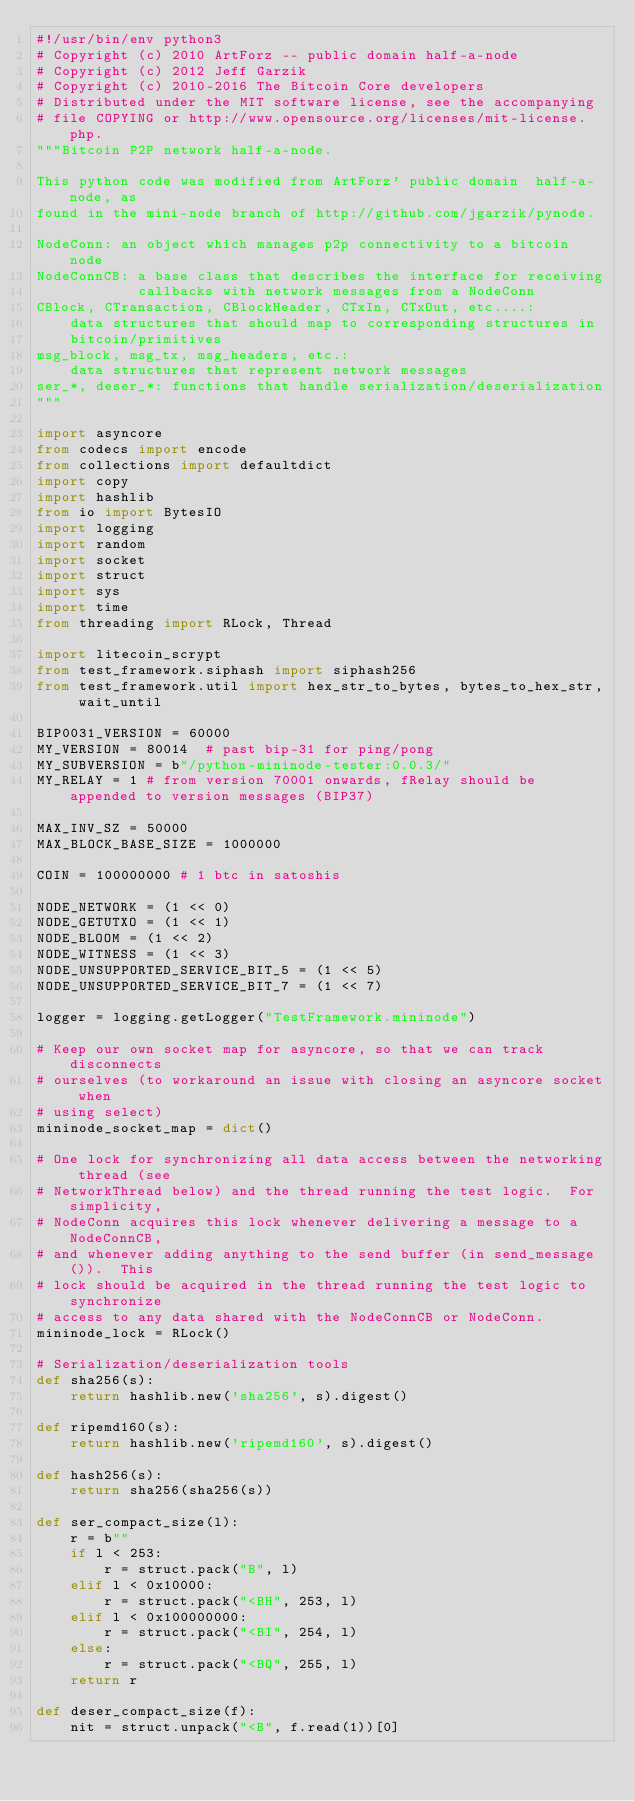<code> <loc_0><loc_0><loc_500><loc_500><_Python_>#!/usr/bin/env python3
# Copyright (c) 2010 ArtForz -- public domain half-a-node
# Copyright (c) 2012 Jeff Garzik
# Copyright (c) 2010-2016 The Bitcoin Core developers
# Distributed under the MIT software license, see the accompanying
# file COPYING or http://www.opensource.org/licenses/mit-license.php.
"""Bitcoin P2P network half-a-node.

This python code was modified from ArtForz' public domain  half-a-node, as
found in the mini-node branch of http://github.com/jgarzik/pynode.

NodeConn: an object which manages p2p connectivity to a bitcoin node
NodeConnCB: a base class that describes the interface for receiving
            callbacks with network messages from a NodeConn
CBlock, CTransaction, CBlockHeader, CTxIn, CTxOut, etc....:
    data structures that should map to corresponding structures in
    bitcoin/primitives
msg_block, msg_tx, msg_headers, etc.:
    data structures that represent network messages
ser_*, deser_*: functions that handle serialization/deserialization
"""

import asyncore
from codecs import encode
from collections import defaultdict
import copy
import hashlib
from io import BytesIO
import logging
import random
import socket
import struct
import sys
import time
from threading import RLock, Thread

import litecoin_scrypt
from test_framework.siphash import siphash256
from test_framework.util import hex_str_to_bytes, bytes_to_hex_str, wait_until

BIP0031_VERSION = 60000
MY_VERSION = 80014  # past bip-31 for ping/pong
MY_SUBVERSION = b"/python-mininode-tester:0.0.3/"
MY_RELAY = 1 # from version 70001 onwards, fRelay should be appended to version messages (BIP37)

MAX_INV_SZ = 50000
MAX_BLOCK_BASE_SIZE = 1000000

COIN = 100000000 # 1 btc in satoshis

NODE_NETWORK = (1 << 0)
NODE_GETUTXO = (1 << 1)
NODE_BLOOM = (1 << 2)
NODE_WITNESS = (1 << 3)
NODE_UNSUPPORTED_SERVICE_BIT_5 = (1 << 5)
NODE_UNSUPPORTED_SERVICE_BIT_7 = (1 << 7)

logger = logging.getLogger("TestFramework.mininode")

# Keep our own socket map for asyncore, so that we can track disconnects
# ourselves (to workaround an issue with closing an asyncore socket when
# using select)
mininode_socket_map = dict()

# One lock for synchronizing all data access between the networking thread (see
# NetworkThread below) and the thread running the test logic.  For simplicity,
# NodeConn acquires this lock whenever delivering a message to a NodeConnCB,
# and whenever adding anything to the send buffer (in send_message()).  This
# lock should be acquired in the thread running the test logic to synchronize
# access to any data shared with the NodeConnCB or NodeConn.
mininode_lock = RLock()

# Serialization/deserialization tools
def sha256(s):
    return hashlib.new('sha256', s).digest()

def ripemd160(s):
    return hashlib.new('ripemd160', s).digest()

def hash256(s):
    return sha256(sha256(s))

def ser_compact_size(l):
    r = b""
    if l < 253:
        r = struct.pack("B", l)
    elif l < 0x10000:
        r = struct.pack("<BH", 253, l)
    elif l < 0x100000000:
        r = struct.pack("<BI", 254, l)
    else:
        r = struct.pack("<BQ", 255, l)
    return r

def deser_compact_size(f):
    nit = struct.unpack("<B", f.read(1))[0]</code> 